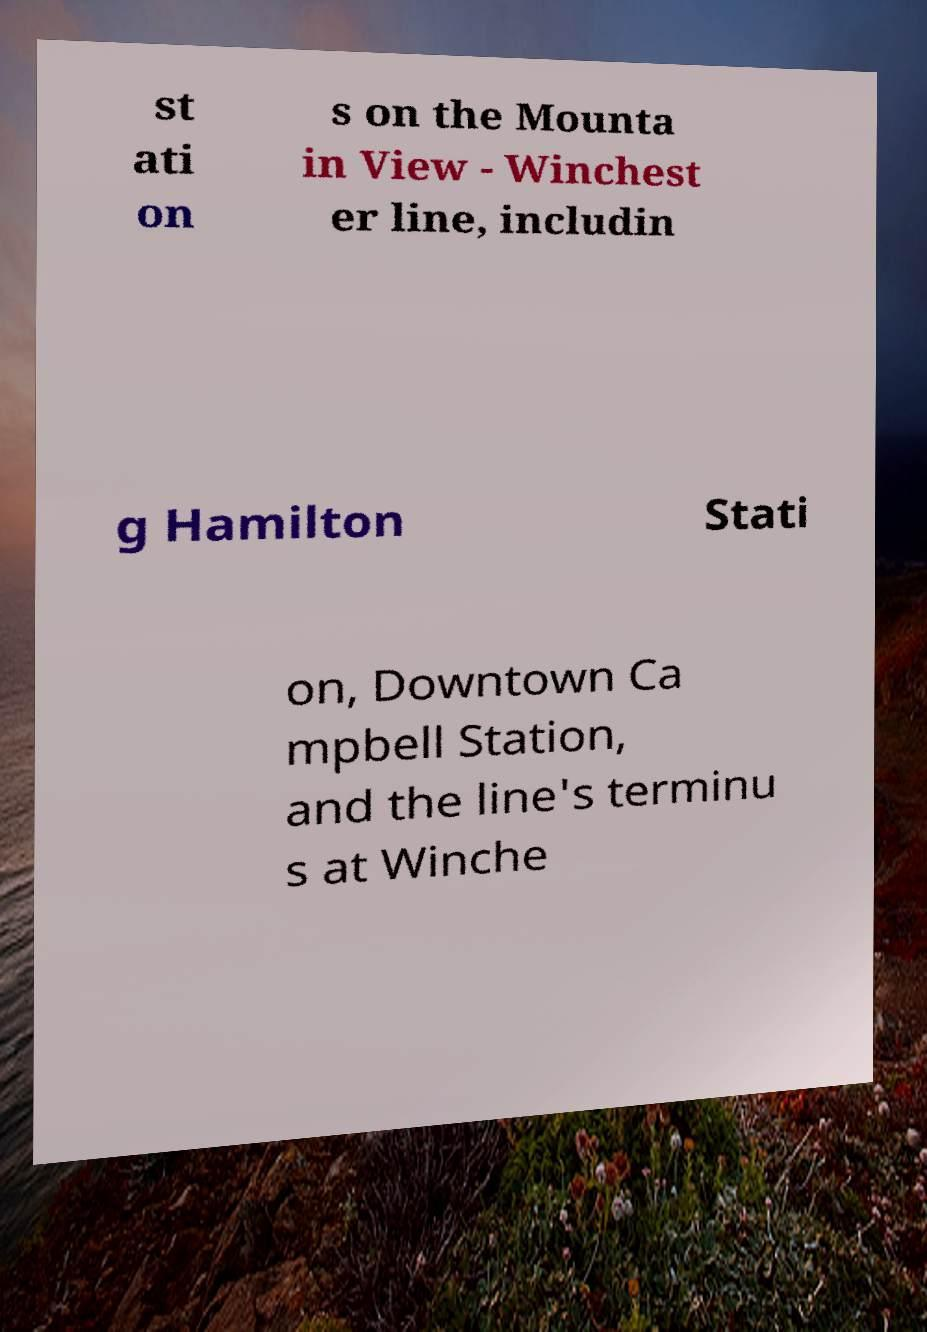Can you accurately transcribe the text from the provided image for me? st ati on s on the Mounta in View - Winchest er line, includin g Hamilton Stati on, Downtown Ca mpbell Station, and the line's terminu s at Winche 